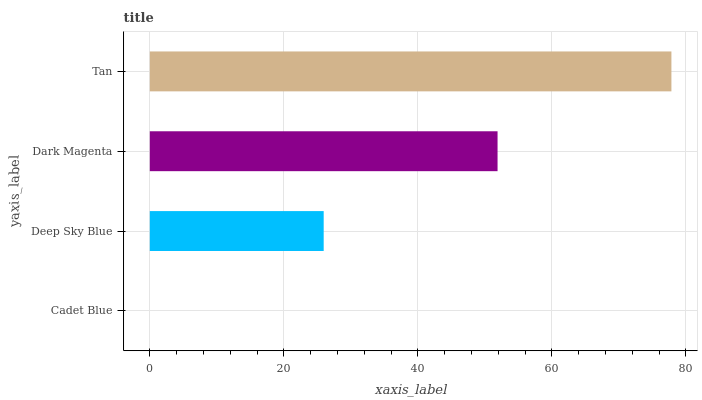Is Cadet Blue the minimum?
Answer yes or no. Yes. Is Tan the maximum?
Answer yes or no. Yes. Is Deep Sky Blue the minimum?
Answer yes or no. No. Is Deep Sky Blue the maximum?
Answer yes or no. No. Is Deep Sky Blue greater than Cadet Blue?
Answer yes or no. Yes. Is Cadet Blue less than Deep Sky Blue?
Answer yes or no. Yes. Is Cadet Blue greater than Deep Sky Blue?
Answer yes or no. No. Is Deep Sky Blue less than Cadet Blue?
Answer yes or no. No. Is Dark Magenta the high median?
Answer yes or no. Yes. Is Deep Sky Blue the low median?
Answer yes or no. Yes. Is Tan the high median?
Answer yes or no. No. Is Tan the low median?
Answer yes or no. No. 